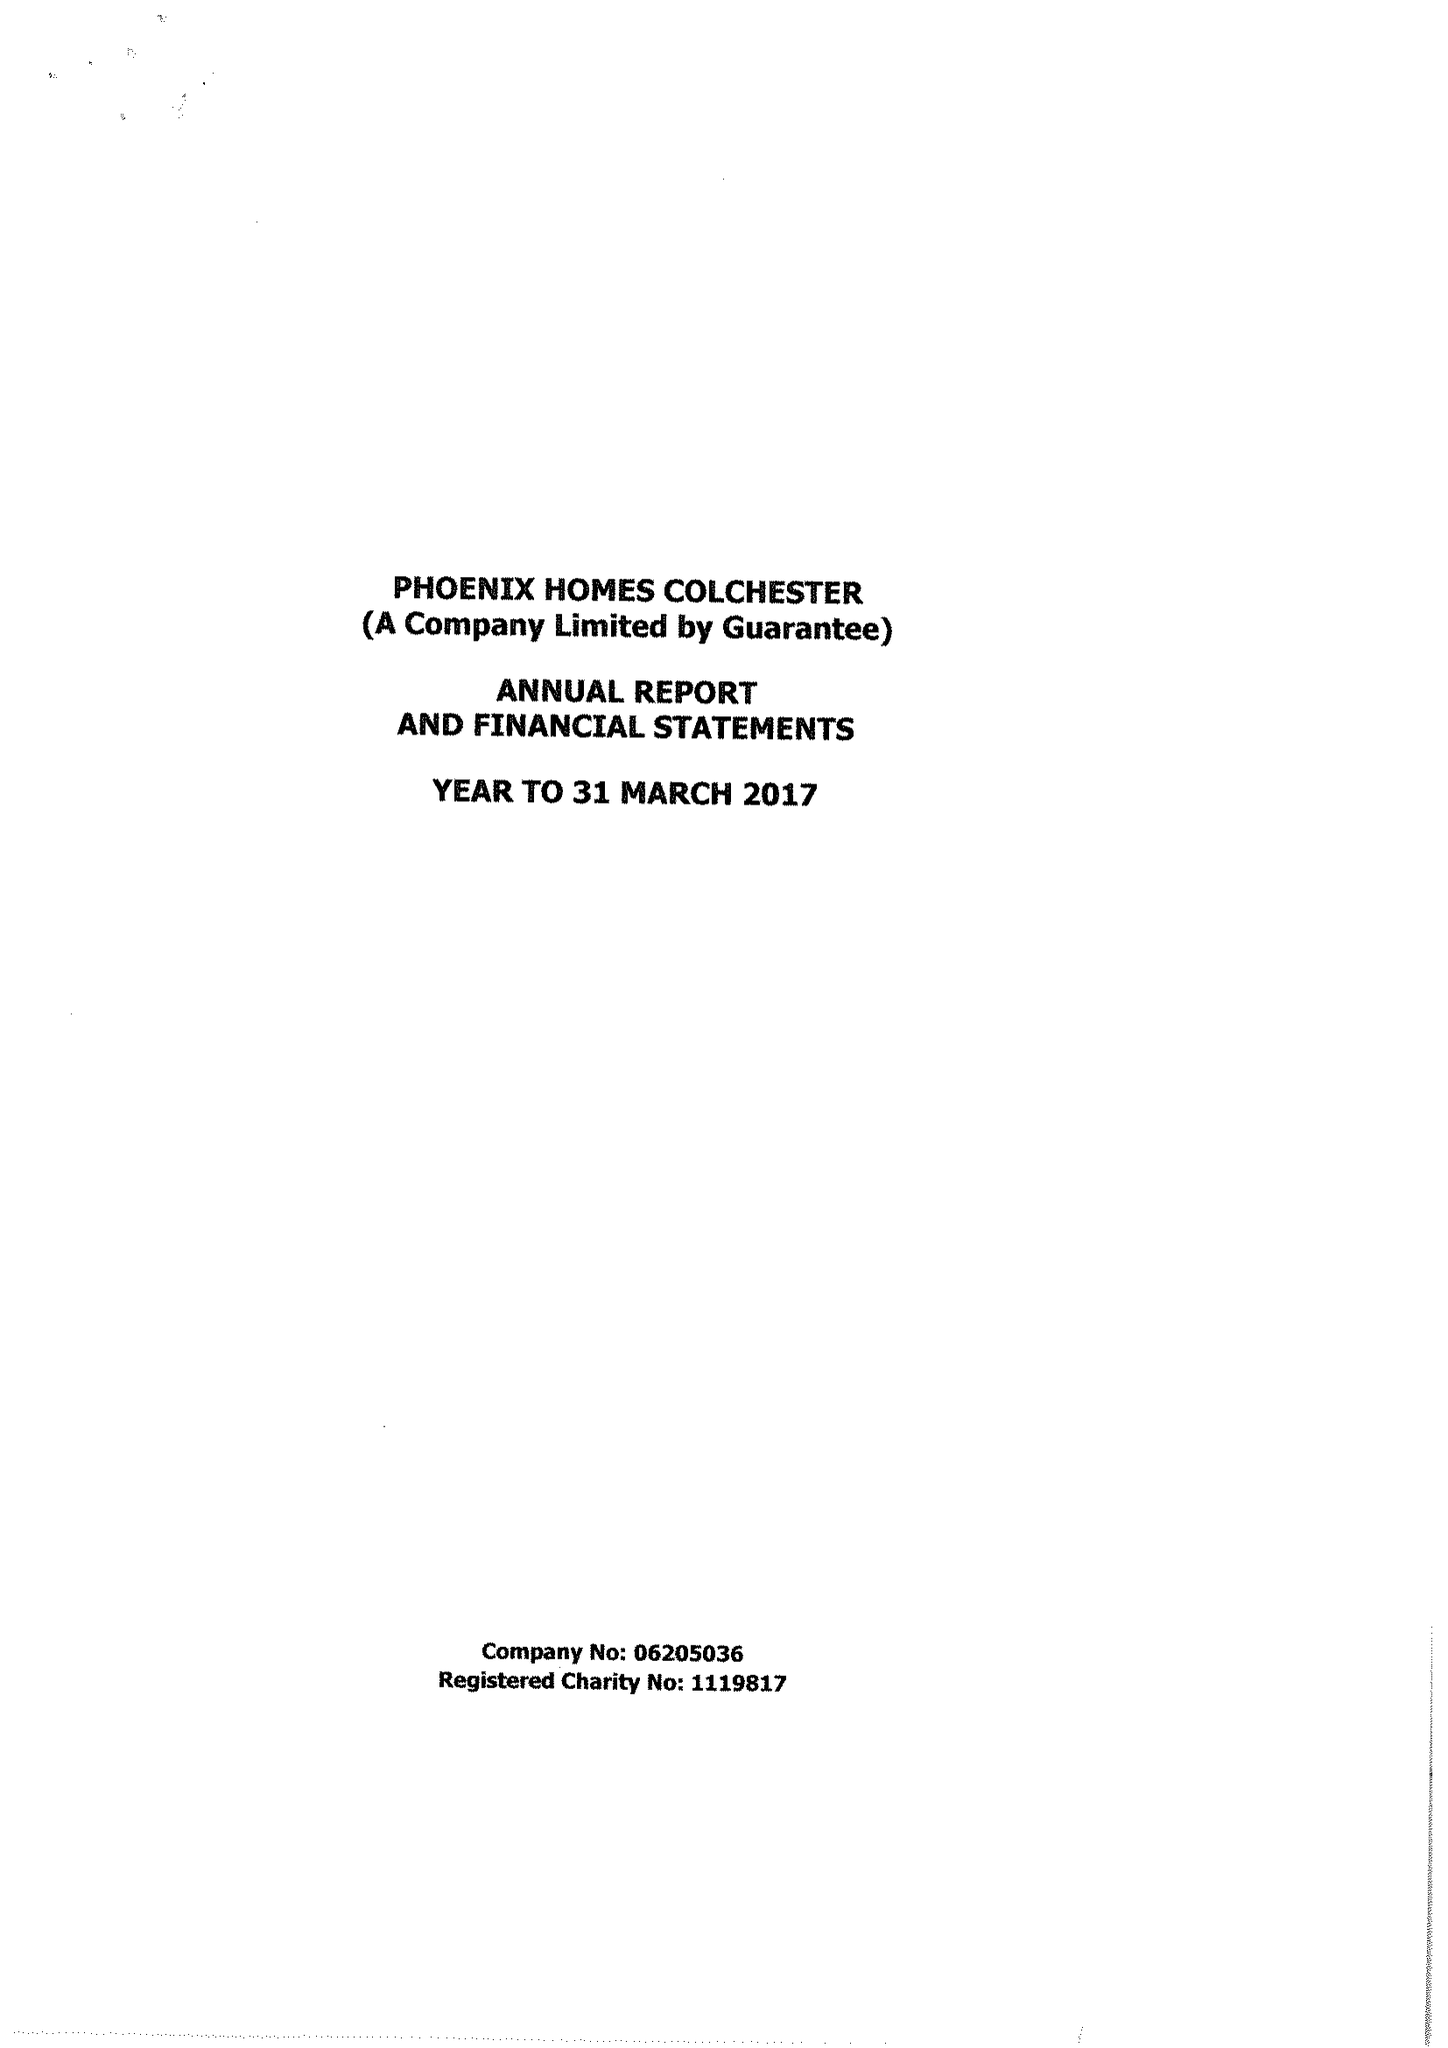What is the value for the address__street_line?
Answer the question using a single word or phrase. 147 STRAIGHT ROAD 